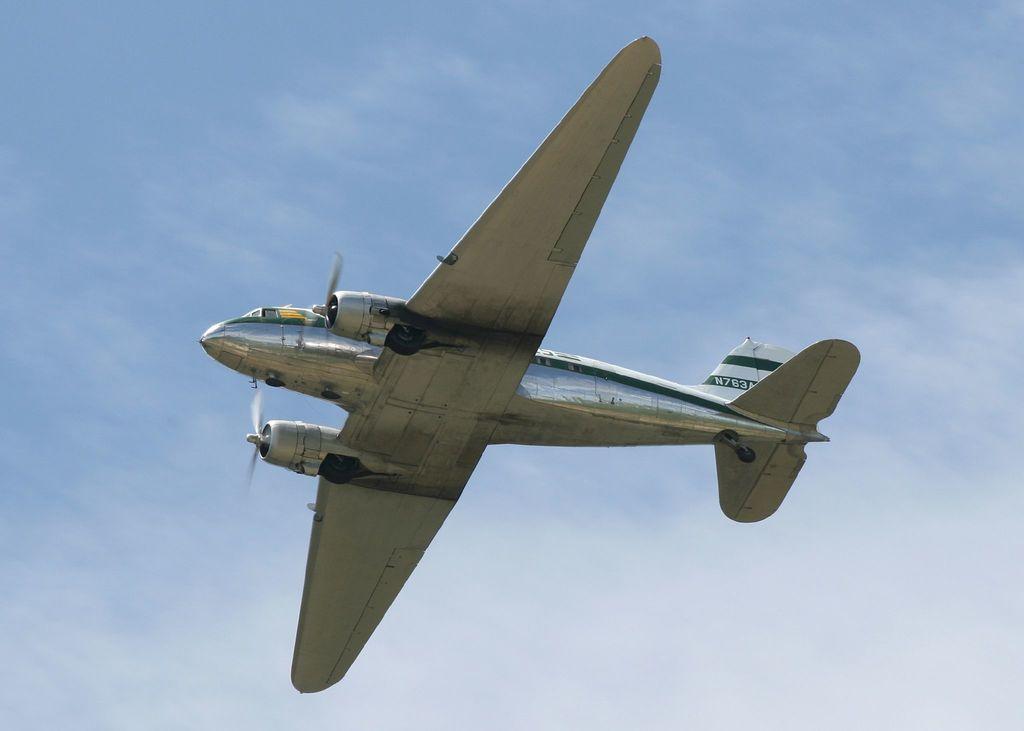Describe this image in one or two sentences. In this image I can see in the middle an aeroplane is flying in the sky. 